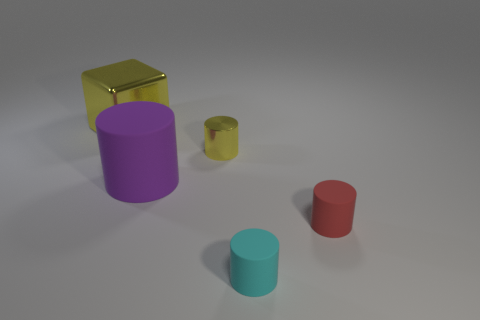Subtract all blue cylinders. Subtract all brown blocks. How many cylinders are left? 4 Add 1 yellow metallic things. How many objects exist? 6 Subtract all cylinders. How many objects are left? 1 Add 5 tiny yellow metallic cylinders. How many tiny yellow metallic cylinders are left? 6 Add 5 tiny gray metallic cubes. How many tiny gray metallic cubes exist? 5 Subtract 0 red balls. How many objects are left? 5 Subtract all red things. Subtract all tiny cyan things. How many objects are left? 3 